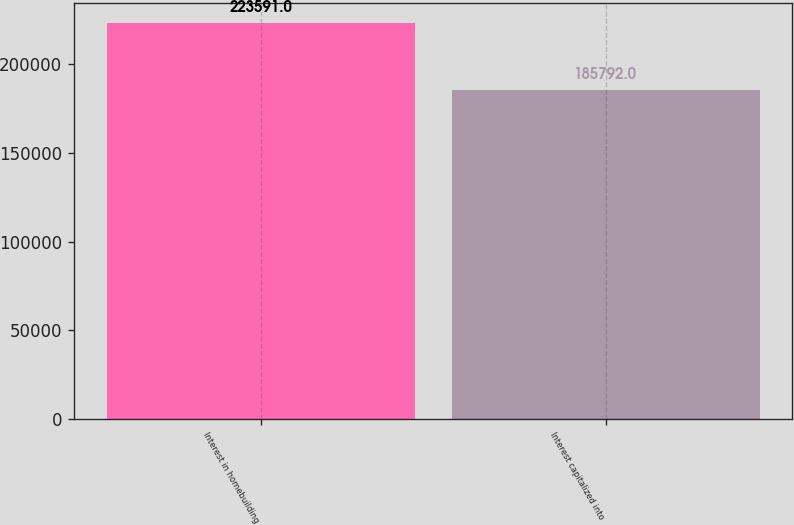Convert chart. <chart><loc_0><loc_0><loc_500><loc_500><bar_chart><fcel>Interest in homebuilding<fcel>Interest capitalized into<nl><fcel>223591<fcel>185792<nl></chart> 